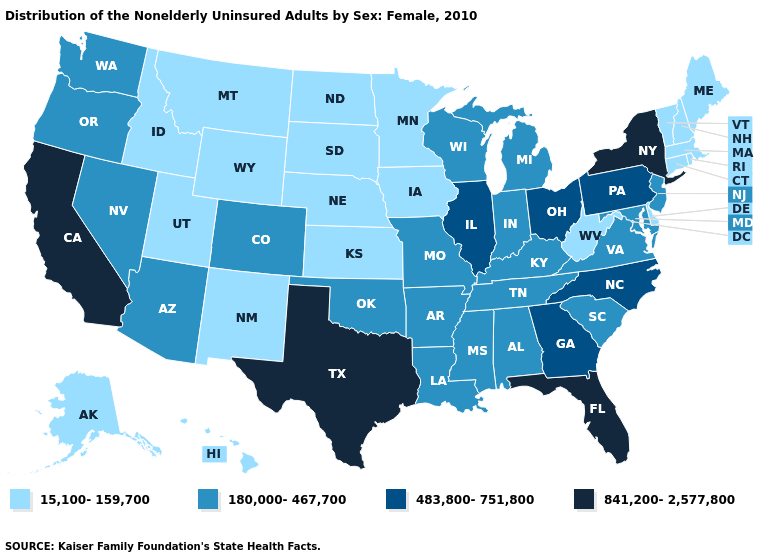What is the value of Minnesota?
Keep it brief. 15,100-159,700. Name the states that have a value in the range 483,800-751,800?
Write a very short answer. Georgia, Illinois, North Carolina, Ohio, Pennsylvania. Does the first symbol in the legend represent the smallest category?
Write a very short answer. Yes. Is the legend a continuous bar?
Be succinct. No. Does Minnesota have the highest value in the MidWest?
Concise answer only. No. Does Rhode Island have a lower value than Georgia?
Short answer required. Yes. Name the states that have a value in the range 841,200-2,577,800?
Concise answer only. California, Florida, New York, Texas. Which states hav the highest value in the West?
Write a very short answer. California. What is the value of Mississippi?
Quick response, please. 180,000-467,700. What is the highest value in the South ?
Answer briefly. 841,200-2,577,800. Does the map have missing data?
Give a very brief answer. No. What is the lowest value in the Northeast?
Give a very brief answer. 15,100-159,700. Does the first symbol in the legend represent the smallest category?
Write a very short answer. Yes. Name the states that have a value in the range 841,200-2,577,800?
Quick response, please. California, Florida, New York, Texas. Among the states that border Georgia , does Tennessee have the lowest value?
Give a very brief answer. Yes. 